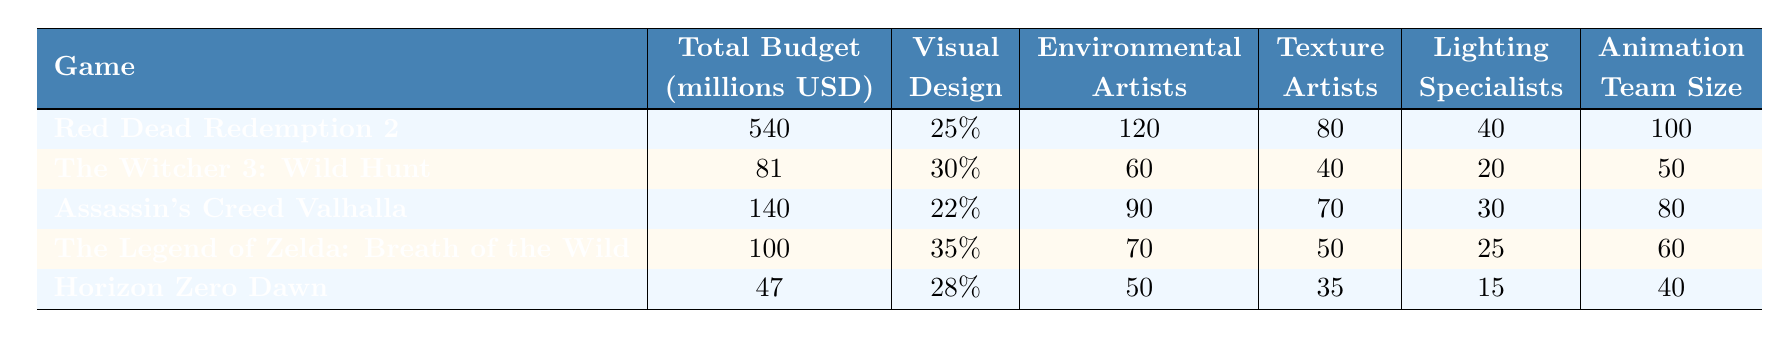What is the total budget allocated to "Horizon Zero Dawn"? The table shows that the total budget for "Horizon Zero Dawn" is listed directly under the "Total Budget" column. It indicates a value of 47 million USD.
Answer: 47 million USD Which game has the highest percentage allocated to visual design? By reviewing the "Visual Design" column, "The Legend of Zelda: Breath of the Wild" is noted with the highest percentage at 35%.
Answer: The Legend of Zelda: Breath of the Wild How many environmental artists worked on "Red Dead Redemption 2"? The table specifies that for "Red Dead Redemption 2," the number of environmental artists is listed as 120 in the corresponding column.
Answer: 120 What is the total number of lighting specialists across all games? To find the total, we add the lighting specialists from each game: 40 + 20 + 30 + 25 + 15 = 140.
Answer: 140 Is the total budget for "Assassin's Creed Valhalla" greater than "The Witcher 3: Wild Hunt"? Comparing the total budgets, "Assassin's Creed Valhalla" has a budget of 140 million USD, while "The Witcher 3: Wild Hunt" has a budget of 81 million USD. Since 140 > 81, the statement is true.
Answer: Yes Which game allocated more resources to aesthetic design: "Horizon Zero Dawn" or "The Witcher 3: Wild Hunt"? We can compare the visual design percentages: "Horizon Zero Dawn" has 28%, and "The Witcher 3: Wild Hunt" has 30%. Since 30% > 28%, "The Witcher 3: Wild Hunt" allocated more.
Answer: The Witcher 3: Wild Hunt What is the average number of texture artists across all listed games? To find the average, we sum the texture artists: 80 + 40 + 70 + 50 + 35 = 275. Then we divide by the number of games (5), which gives us 275 / 5 = 55.
Answer: 55 Which publisher has the highest overall budget among the listed games? The total budgets are: Rockstar Games (540), CD Projekt (81), Ubisoft (140), Nintendo (100), and Sony Interactive Entertainment (47). The highest budget is 540 million USD from Rockstar Games.
Answer: Rockstar Games How many total animation team members worked on "The Legend of Zelda: Breath of the Wild"? The table lists that "The Legend of Zelda: Breath of the Wild" had an animation team size of 60.
Answer: 60 Which game has the lowest number of environmental artists? We look at the "Environmental Artists" column and find the lowest value is for "Horizon Zero Dawn," which has 50 environmental artists.
Answer: Horizon Zero Dawn 